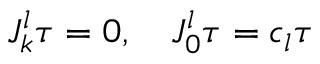Convert formula to latex. <formula><loc_0><loc_0><loc_500><loc_500>J _ { k } ^ { l } \tau = 0 , \quad J _ { 0 } ^ { l } \tau = c _ { l } \tau</formula> 